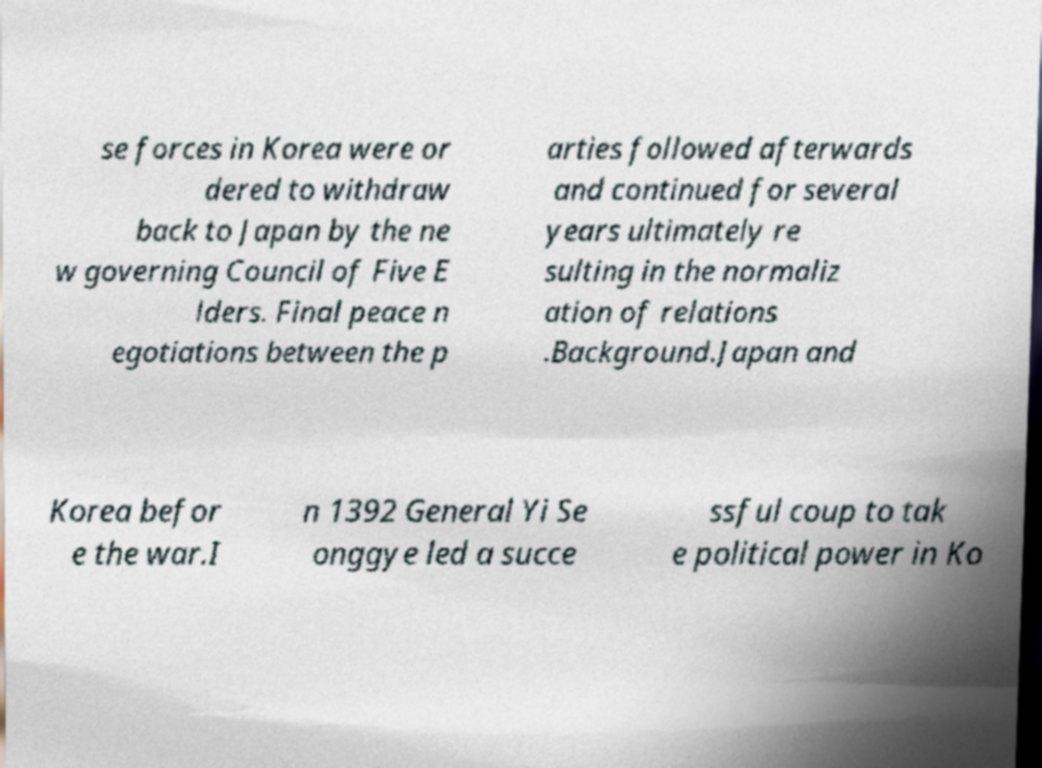I need the written content from this picture converted into text. Can you do that? se forces in Korea were or dered to withdraw back to Japan by the ne w governing Council of Five E lders. Final peace n egotiations between the p arties followed afterwards and continued for several years ultimately re sulting in the normaliz ation of relations .Background.Japan and Korea befor e the war.I n 1392 General Yi Se onggye led a succe ssful coup to tak e political power in Ko 